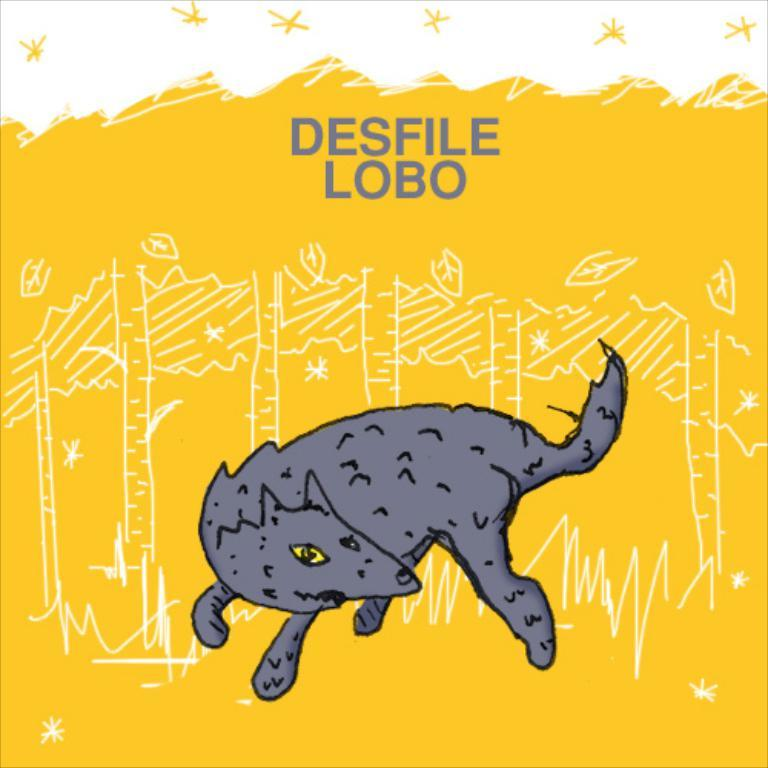What type of visual is shown in the image? The image appears to be a poster. What can be seen at the bottom of the poster? There is a depiction of an animal at the bottom of the poster. What is located at the top of the poster? There is text at the top of the poster. What colors are used in the poster? The poster features yellow and white color painting. What time is displayed on the clock in the image? There is no clock present in the image. How does the fireman help in the image? There is no fireman present in the image. 